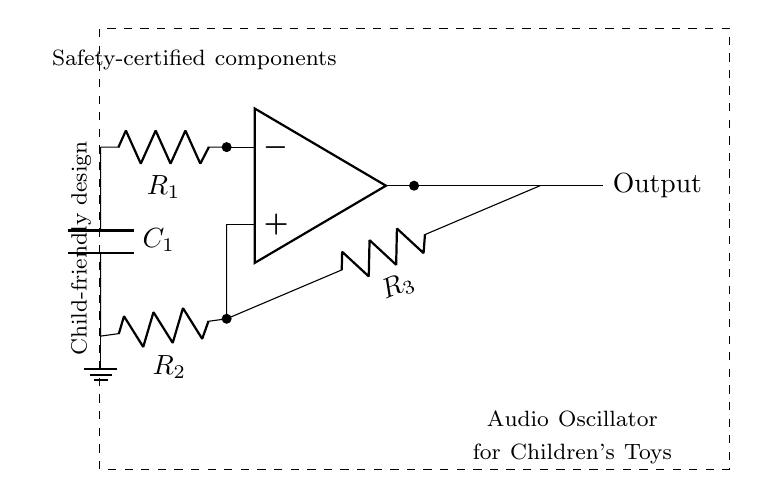What type of circuit is this? This circuit is an oscillator, as indicated by its design to create oscillating signals suitable for generating audio tones.
Answer: oscillator What are the components used in this circuit? The circuit contains an operational amplifier, resistors, and a capacitor, which are fundamental to its operation as an audio oscillator.
Answer: operational amplifier, resistors, capacitor How many resistors are present in the circuit? There are three resistors shown in the circuit, labeled R1, R2, and R3.
Answer: three What does the output of the circuit connect to? The output is connected through a resistor to the feedback loop and also directly marked as "Output," indicating where the audio signal will exit the circuit.
Answer: feedback loop and output node Why is safety mentioned in this circuit? The circuit includes a note about "safety-certified components," emphasizing that the materials used are vetted for safe use, especially since this oscillator is intended for children's toys.
Answer: safety-certified components How does the capacitor affect the oscillator circuit? The capacitor works with the resistors to set the timing and frequency of the oscillation, which determines the pitch of the sound produced by the circuit.
Answer: sets timing and frequency What is the purpose of the operational amplifier in this circuit? The operational amplifier amplifies the input signal and is crucial for the oscillation process, ensuring that the signal generated is strong enough for audio output.
Answer: amplifies the signal 